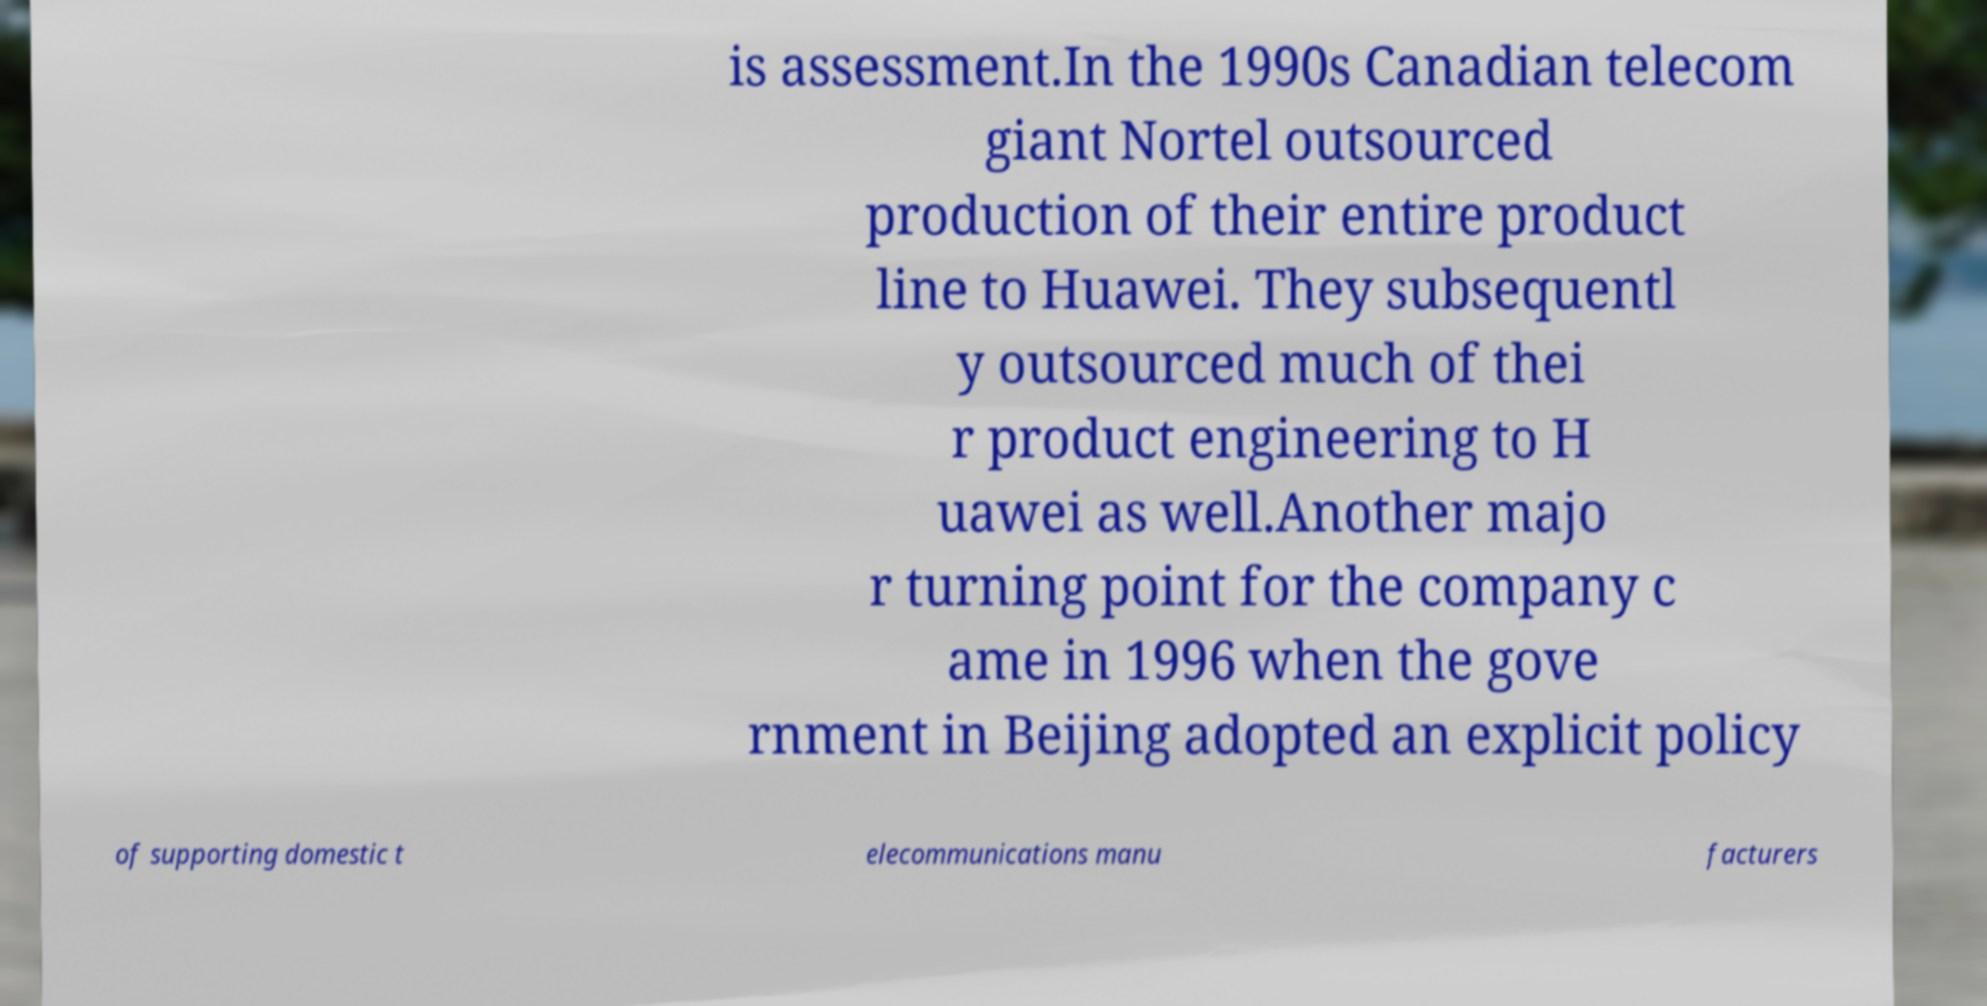What messages or text are displayed in this image? I need them in a readable, typed format. is assessment.In the 1990s Canadian telecom giant Nortel outsourced production of their entire product line to Huawei. They subsequentl y outsourced much of thei r product engineering to H uawei as well.Another majo r turning point for the company c ame in 1996 when the gove rnment in Beijing adopted an explicit policy of supporting domestic t elecommunications manu facturers 